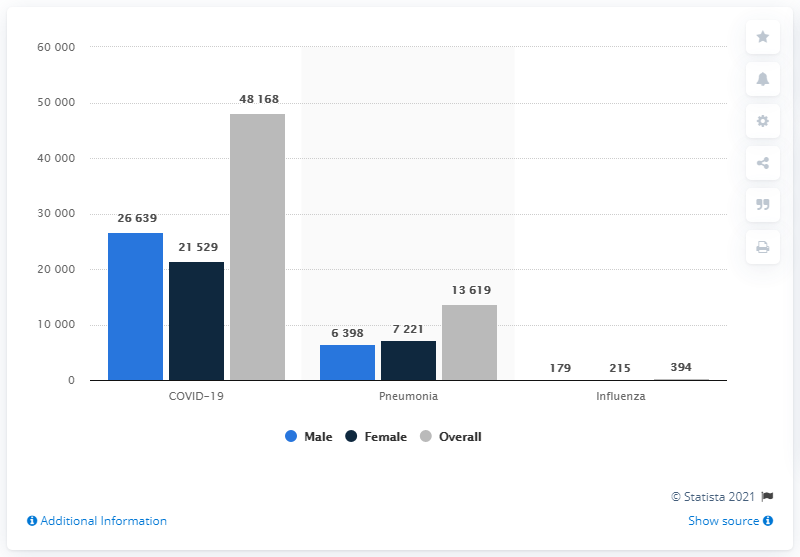Outline some significant characteristics in this image. During the period of January to August 2020, a total of 48,168 deaths in England and Wales had COVID-19 as the underlying cause. 